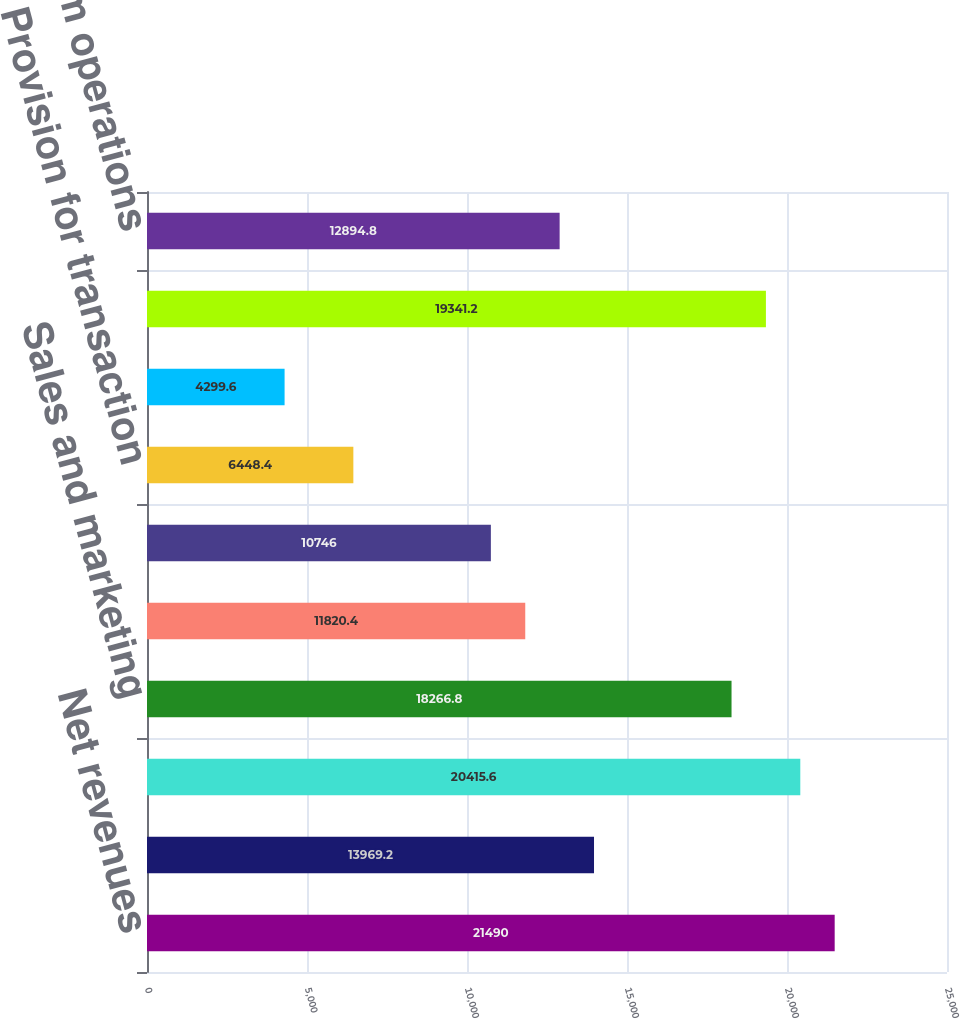Convert chart. <chart><loc_0><loc_0><loc_500><loc_500><bar_chart><fcel>Net revenues<fcel>Cost of net revenues<fcel>Gross profit<fcel>Sales and marketing<fcel>Product development<fcel>General and administrative<fcel>Provision for transaction<fcel>Amortization of acquired<fcel>Total operating expenses<fcel>Income from operations<nl><fcel>21490<fcel>13969.2<fcel>20415.6<fcel>18266.8<fcel>11820.4<fcel>10746<fcel>6448.4<fcel>4299.6<fcel>19341.2<fcel>12894.8<nl></chart> 